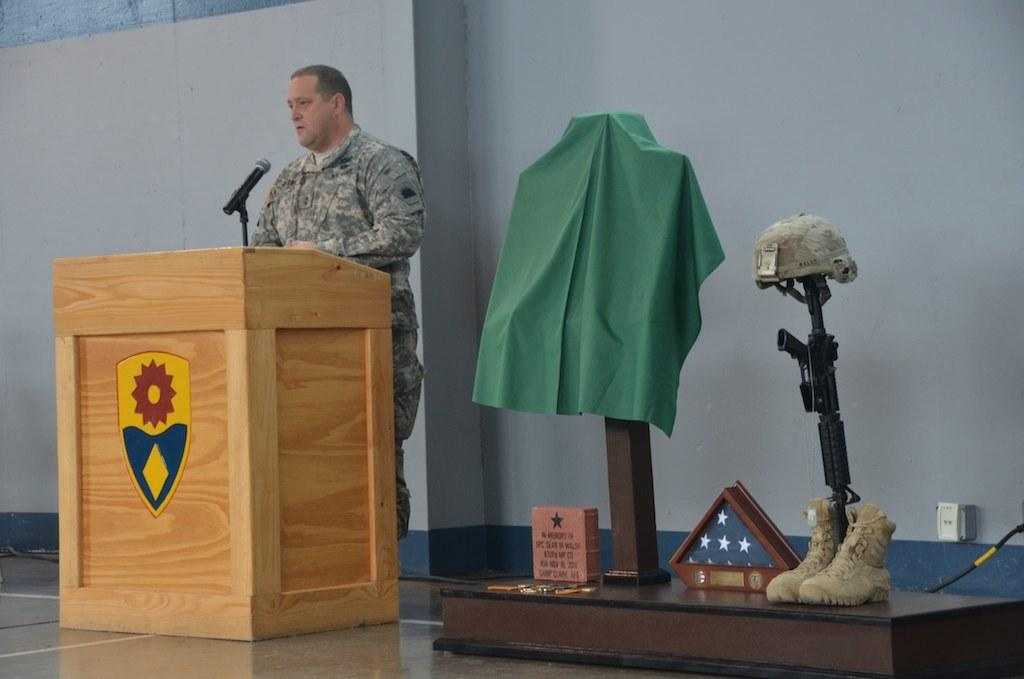What is the man in the image doing? The man is talking on the mike. What object is present in the image that is commonly used for speeches or presentations? There is a podium in the image. What type of footwear can be seen in the image? Shoes are visible in the image. What potentially dangerous object is present in the image? A weapon is present in the image. What type of headwear is visible in the image? There is a cap in the image. What material is present in the image that can be used for clothing or other purposes? Cloth is present in the image. What part of the environment can be seen in the image? The floor is visible in the image. What type of background can be seen in the image? There is a wall in the background of the image. How does the man apply the brake while talking on the mike in the image? There is no reference to a vehicle or a brake in the image; the man is talking on the mike while standing near a podium. 